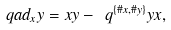<formula> <loc_0><loc_0><loc_500><loc_500>\ q a d _ { x } y = x y - \ q ^ { \{ \# x , \# y \} } y x ,</formula> 